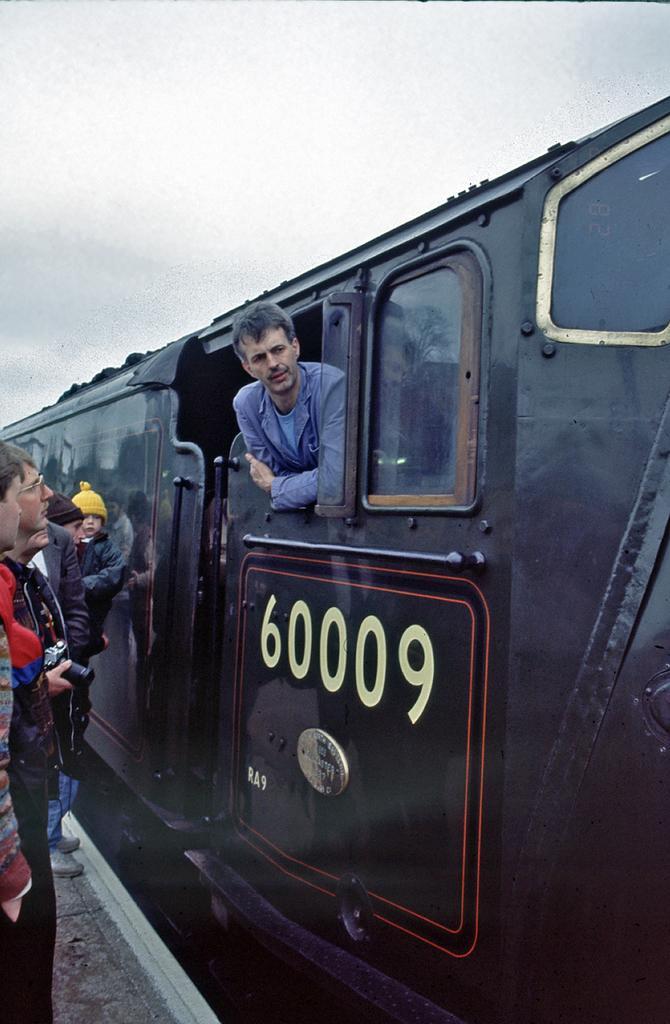Please provide a concise description of this image. In the image there is a train with glass window. And there is a man in the train. On the left side of the image on the platform there are few people standing. At the top of the image there is sky. 